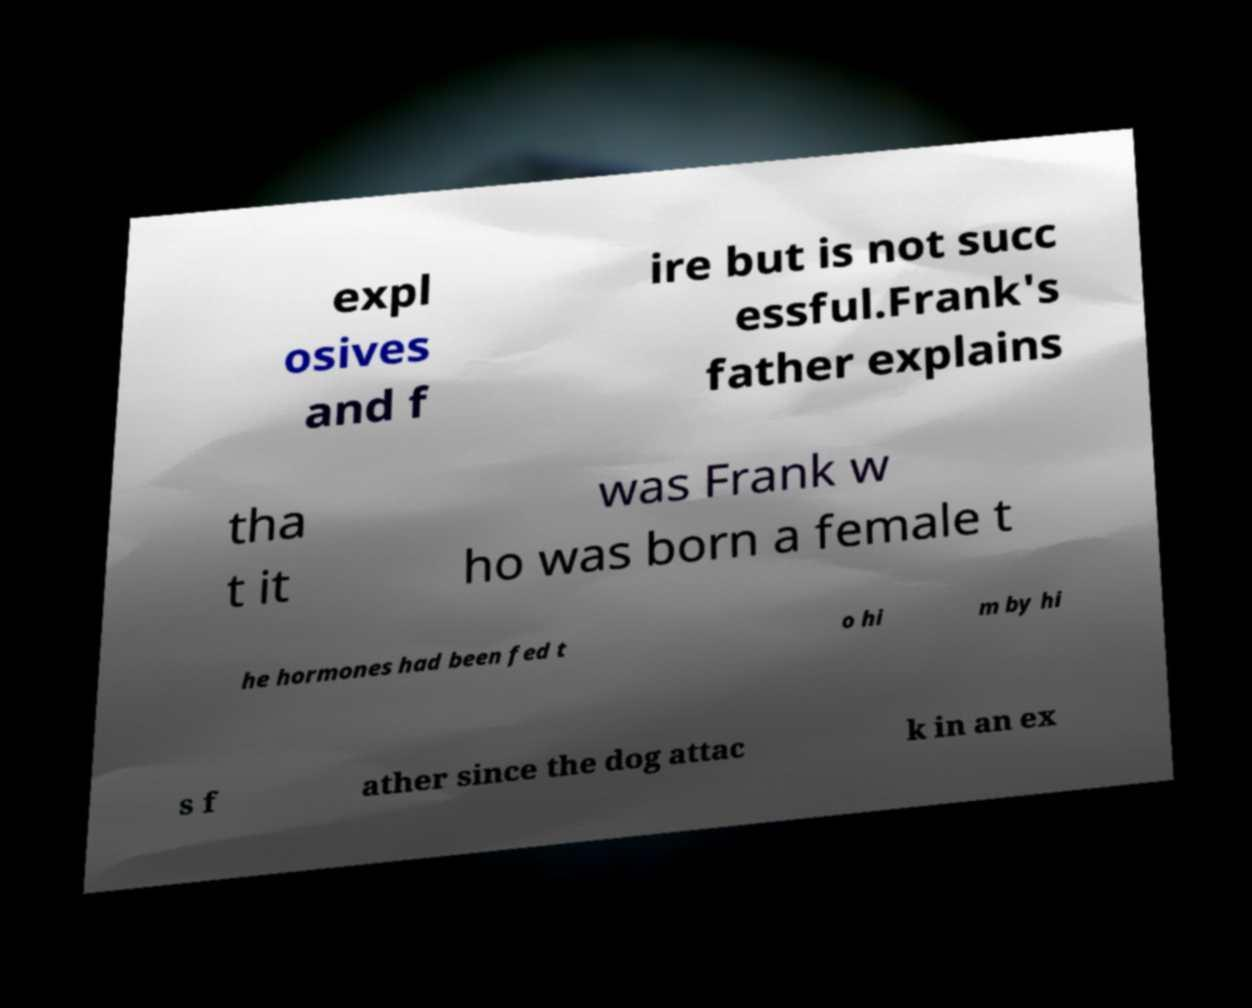Can you accurately transcribe the text from the provided image for me? expl osives and f ire but is not succ essful.Frank's father explains tha t it was Frank w ho was born a female t he hormones had been fed t o hi m by hi s f ather since the dog attac k in an ex 